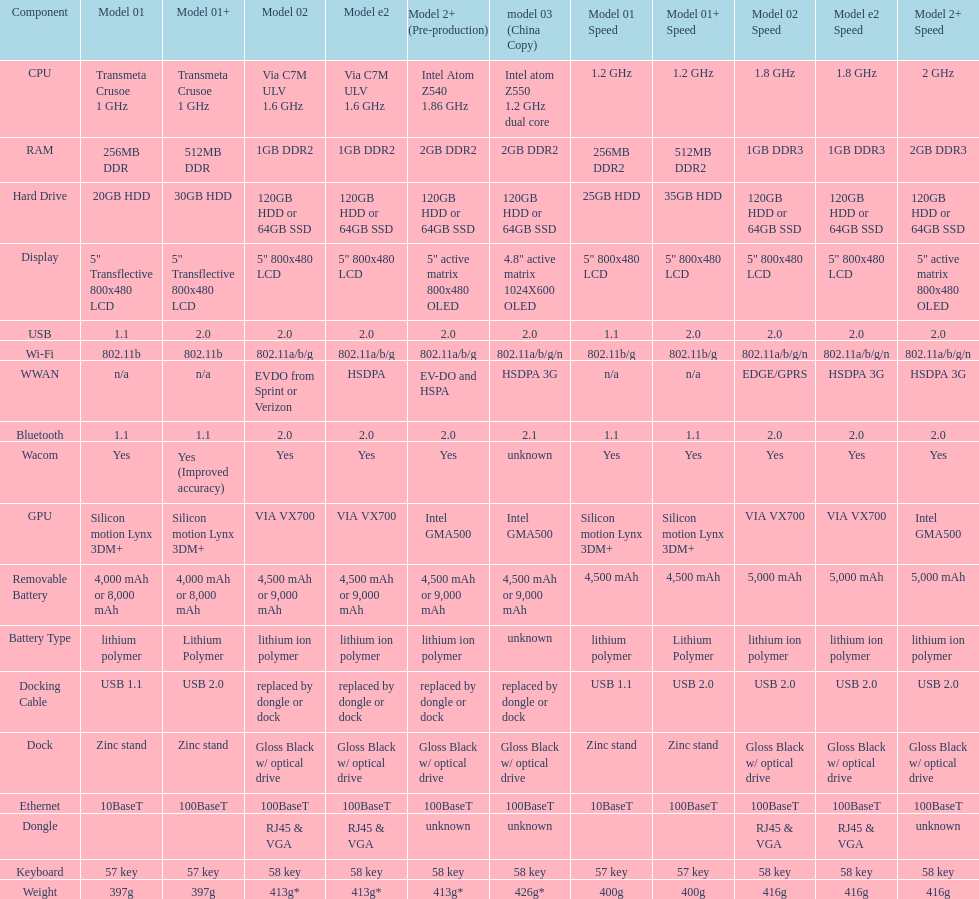What is the hard drive capacity that comes after the 30gb version? 64GB SSD. 